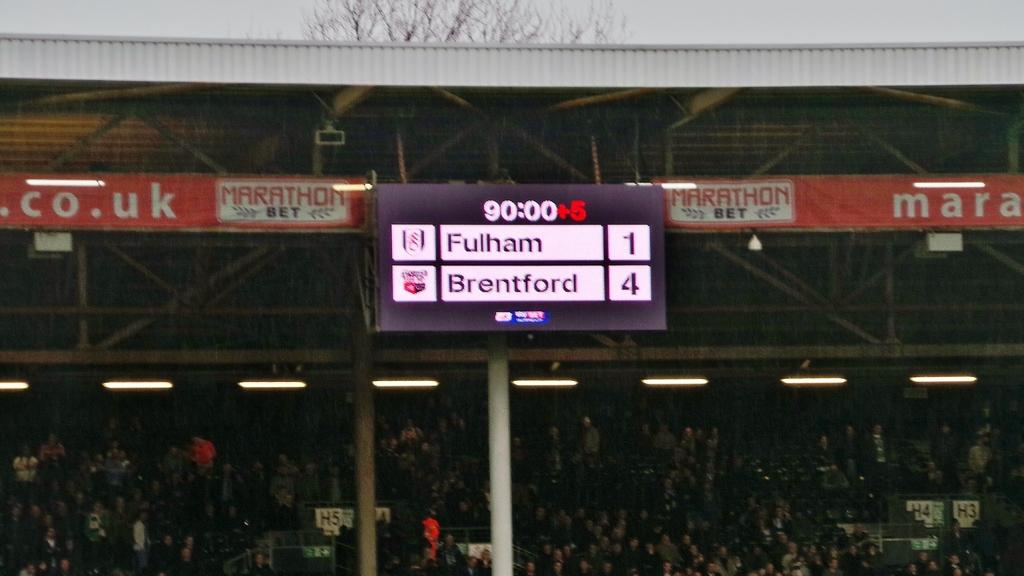<image>
Summarize the visual content of the image. A scoreboard showing Fulham as having 1 point and Brentford having 4 points. 